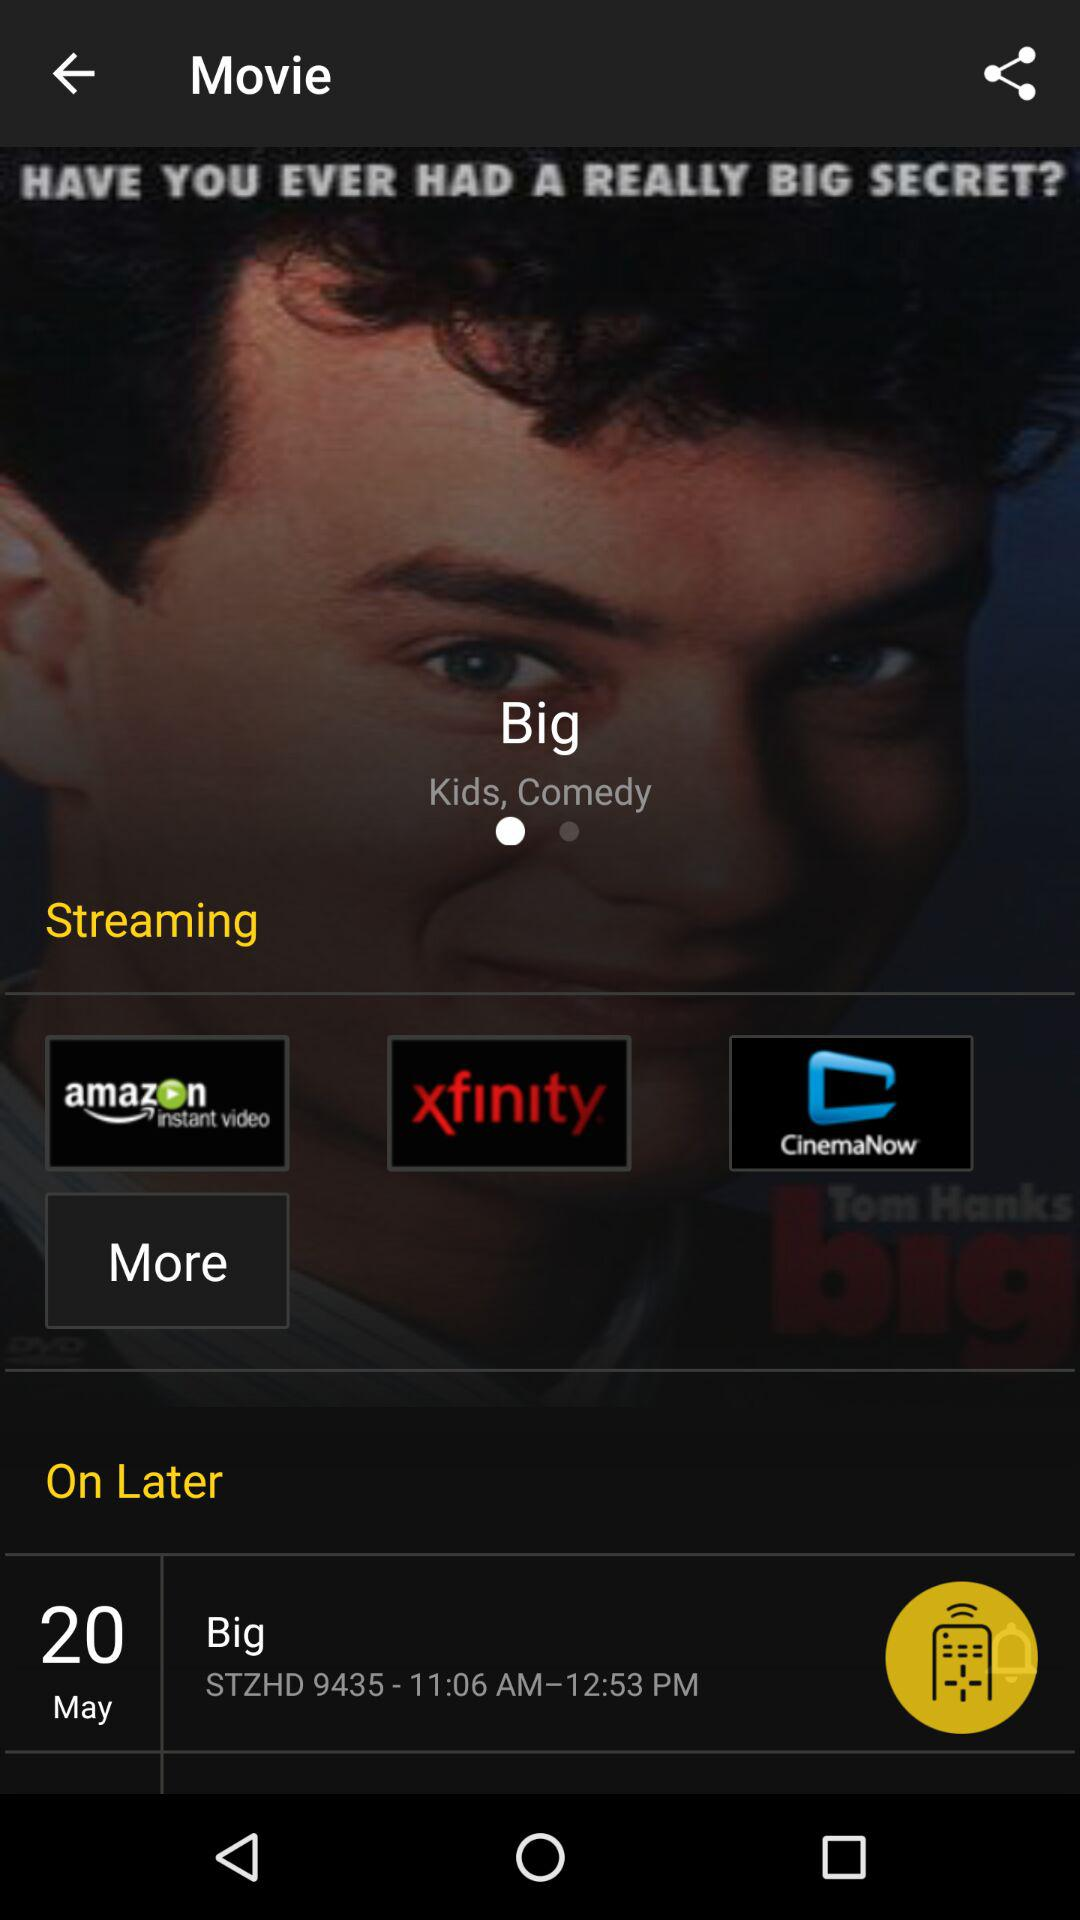What is the time for the "Big" movie? The time for the "Big" movie is 11:06 AM to 12:53 PM. 